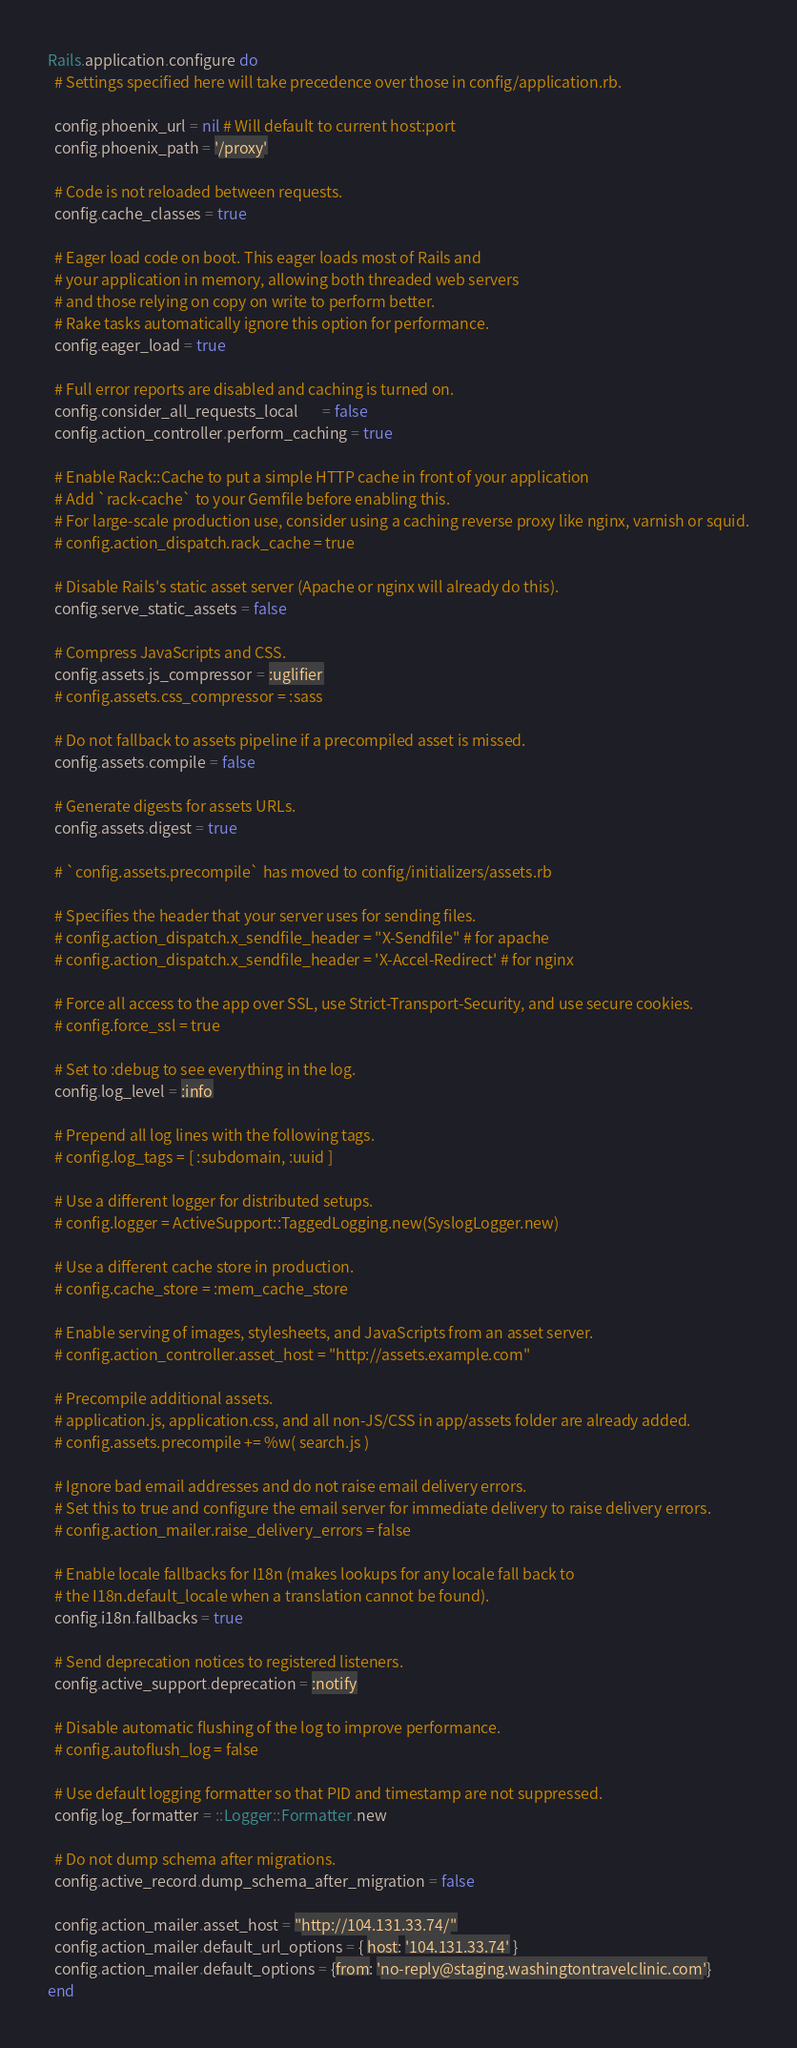<code> <loc_0><loc_0><loc_500><loc_500><_Ruby_>Rails.application.configure do
  # Settings specified here will take precedence over those in config/application.rb.

  config.phoenix_url = nil # Will default to current host:port
  config.phoenix_path = '/proxy'

  # Code is not reloaded between requests.
  config.cache_classes = true

  # Eager load code on boot. This eager loads most of Rails and
  # your application in memory, allowing both threaded web servers
  # and those relying on copy on write to perform better.
  # Rake tasks automatically ignore this option for performance.
  config.eager_load = true

  # Full error reports are disabled and caching is turned on.
  config.consider_all_requests_local       = false
  config.action_controller.perform_caching = true

  # Enable Rack::Cache to put a simple HTTP cache in front of your application
  # Add `rack-cache` to your Gemfile before enabling this.
  # For large-scale production use, consider using a caching reverse proxy like nginx, varnish or squid.
  # config.action_dispatch.rack_cache = true

  # Disable Rails's static asset server (Apache or nginx will already do this).
  config.serve_static_assets = false

  # Compress JavaScripts and CSS.
  config.assets.js_compressor = :uglifier
  # config.assets.css_compressor = :sass

  # Do not fallback to assets pipeline if a precompiled asset is missed.
  config.assets.compile = false

  # Generate digests for assets URLs.
  config.assets.digest = true

  # `config.assets.precompile` has moved to config/initializers/assets.rb

  # Specifies the header that your server uses for sending files.
  # config.action_dispatch.x_sendfile_header = "X-Sendfile" # for apache
  # config.action_dispatch.x_sendfile_header = 'X-Accel-Redirect' # for nginx

  # Force all access to the app over SSL, use Strict-Transport-Security, and use secure cookies.
  # config.force_ssl = true

  # Set to :debug to see everything in the log.
  config.log_level = :info

  # Prepend all log lines with the following tags.
  # config.log_tags = [ :subdomain, :uuid ]

  # Use a different logger for distributed setups.
  # config.logger = ActiveSupport::TaggedLogging.new(SyslogLogger.new)

  # Use a different cache store in production.
  # config.cache_store = :mem_cache_store

  # Enable serving of images, stylesheets, and JavaScripts from an asset server.
  # config.action_controller.asset_host = "http://assets.example.com"

  # Precompile additional assets.
  # application.js, application.css, and all non-JS/CSS in app/assets folder are already added.
  # config.assets.precompile += %w( search.js )

  # Ignore bad email addresses and do not raise email delivery errors.
  # Set this to true and configure the email server for immediate delivery to raise delivery errors.
  # config.action_mailer.raise_delivery_errors = false

  # Enable locale fallbacks for I18n (makes lookups for any locale fall back to
  # the I18n.default_locale when a translation cannot be found).
  config.i18n.fallbacks = true

  # Send deprecation notices to registered listeners.
  config.active_support.deprecation = :notify

  # Disable automatic flushing of the log to improve performance.
  # config.autoflush_log = false

  # Use default logging formatter so that PID and timestamp are not suppressed.
  config.log_formatter = ::Logger::Formatter.new

  # Do not dump schema after migrations.
  config.active_record.dump_schema_after_migration = false

  config.action_mailer.asset_host = "http://104.131.33.74/"
  config.action_mailer.default_url_options = { host: '104.131.33.74' }
  config.action_mailer.default_options = {from: 'no-reply@staging.washingtontravelclinic.com'}
end
</code> 